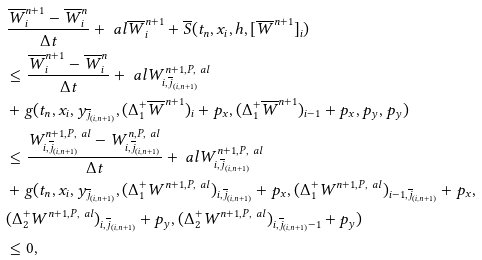Convert formula to latex. <formula><loc_0><loc_0><loc_500><loc_500>& \frac { \overline { W } _ { i } ^ { n + 1 } - \overline { W } _ { i } ^ { n } } { \Delta t } + \ a l \overline { W } _ { i } ^ { n + 1 } + \overline { S } ( t _ { n } , x _ { i } , h , [ \overline { W } ^ { n + 1 } ] _ { i } ) \\ & \leq \frac { \overline { W } _ { i } ^ { n + 1 } - \overline { W } _ { i } ^ { n } } { \Delta t } + \ a l W _ { i , \overline { j } _ { ( i , n + 1 ) } } ^ { n + 1 , P , \ a l } \\ & + g ( t _ { n } , x _ { i } , y _ { \overline { j } _ { ( i , n + 1 ) } } , ( \Delta _ { 1 } ^ { + } \overline { W } ^ { n + 1 } ) _ { i } + p _ { x } , ( \Delta _ { 1 } ^ { + } \overline { W } ^ { n + 1 } ) _ { i - 1 } + p _ { x } , p _ { y } , p _ { y } ) \\ & \leq \frac { W _ { i , \overline { j } _ { ( i , n + 1 ) } } ^ { n + 1 , P , \ a l } - W _ { i , \overline { j } _ { ( i , n + 1 ) } } ^ { n , P , \ a l } } { \Delta t } + \ a l W _ { i , \overline { j } _ { ( i , n + 1 ) } } ^ { n + 1 , P , \ a l } \\ & + g ( t _ { n } , x _ { i } , y _ { \overline { j } _ { ( i , n + 1 ) } } , ( \Delta _ { 1 } ^ { + } W ^ { n + 1 , P , \ a l } ) _ { i , \overline { j } _ { ( i , n + 1 ) } } + p _ { x } , ( \Delta _ { 1 } ^ { + } W ^ { n + 1 , P , \ a l } ) _ { i - 1 , \overline { j } _ { ( i , n + 1 ) } } + p _ { x } , \\ & ( \Delta _ { 2 } ^ { + } W ^ { n + 1 , P , \ a l } ) _ { i , \overline { j } _ { ( i , n + 1 ) } } + p _ { y } , ( \Delta _ { 2 } ^ { + } W ^ { n + 1 , P , \ a l } ) _ { i , \overline { j } _ { ( i , n + 1 ) } - 1 } + p _ { y } ) \\ & \leq 0 ,</formula> 